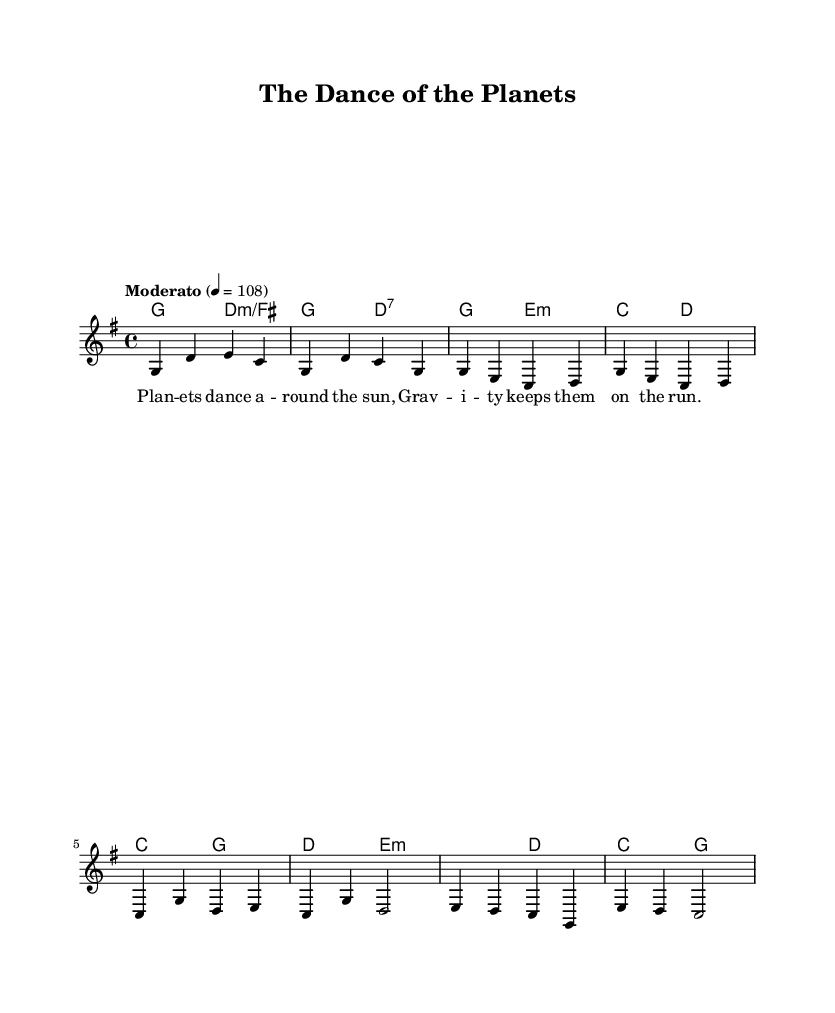What is the key signature of this music? The key signature is G major, which has one sharp (F#). This is indicated at the beginning of the sheet music.
Answer: G major What is the time signature of this piece? The time signature is 4/4, meaning there are four beats in each measure. This is shown in the standard form at the beginning of the music.
Answer: 4/4 What is the tempo marking for this composition? The tempo marking is "Moderato," which suggests a moderate speed for the piece. The BPM (beats per minute) is indicated as 108.
Answer: Moderato How many measures are in the melody section presented? The melody section presented contains a total of 10 measures, which can be counted from the start to the end of the melodic line shown in the sheet music.
Answer: 10 What is the first chord indicated in the harmonies? The first chord indicated in the harmonies is G major. It is notated as the first chord in the chord mode section.
Answer: G What literary theme do the lyrics of this folk song primarily focus on? The lyrics focus on cosmology, particularly the movement of planets and gravitational forces, which is representative of storytelling folk songs that explain cosmic phenomena.
Answer: Cosmology How does the harmony in the chorus contrast with the verse? In the chorus, the harmony shifts to a C major chord, while the verse primarily uses E minor and D major chords. This contrast highlights a different emotional tone in the chorus compared to the verse.
Answer: C major 